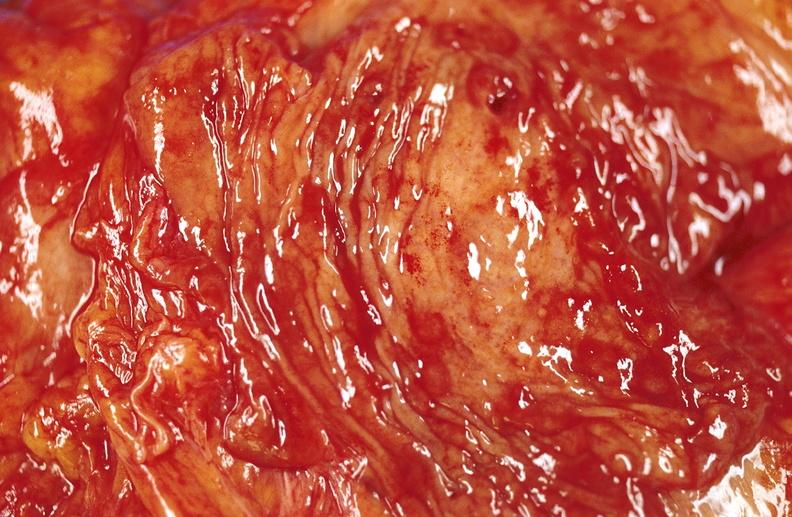what does this image show?
Answer the question using a single word or phrase. Duodenal ulcer 